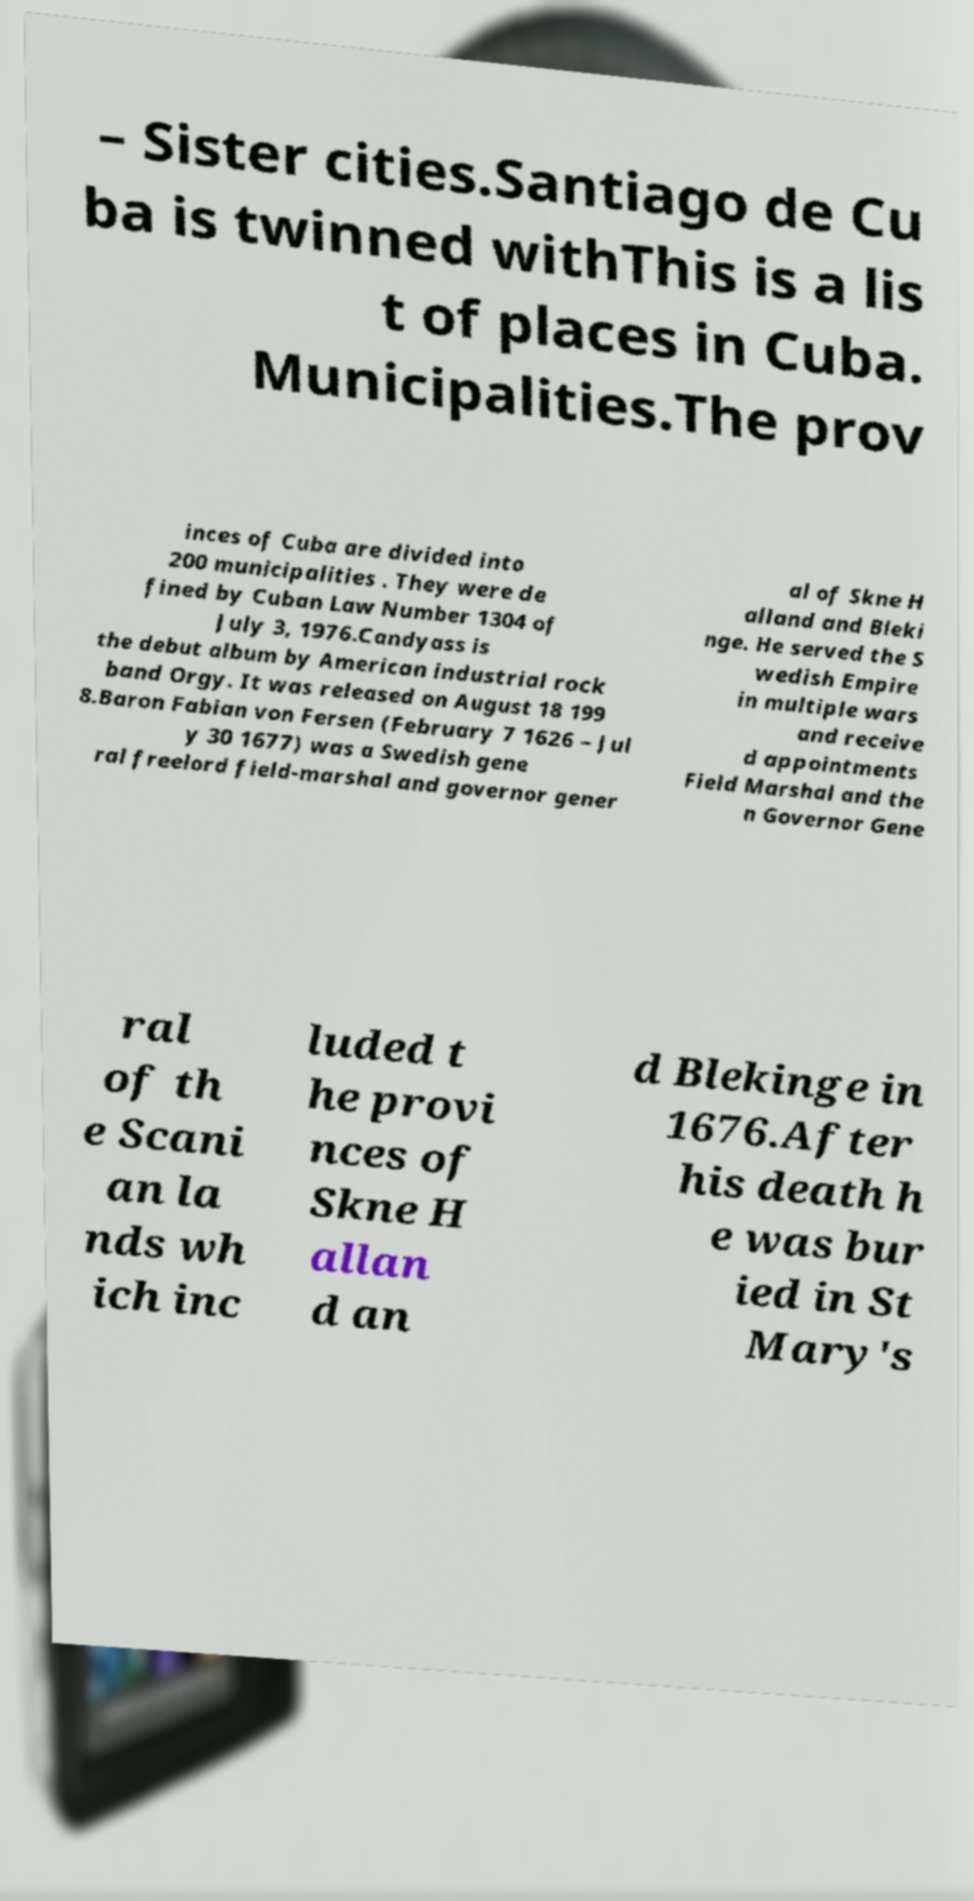What messages or text are displayed in this image? I need them in a readable, typed format. – Sister cities.Santiago de Cu ba is twinned withThis is a lis t of places in Cuba. Municipalities.The prov inces of Cuba are divided into 200 municipalities . They were de fined by Cuban Law Number 1304 of July 3, 1976.Candyass is the debut album by American industrial rock band Orgy. It was released on August 18 199 8.Baron Fabian von Fersen (February 7 1626 – Jul y 30 1677) was a Swedish gene ral freelord field-marshal and governor gener al of Skne H alland and Bleki nge. He served the S wedish Empire in multiple wars and receive d appointments Field Marshal and the n Governor Gene ral of th e Scani an la nds wh ich inc luded t he provi nces of Skne H allan d an d Blekinge in 1676.After his death h e was bur ied in St Mary's 